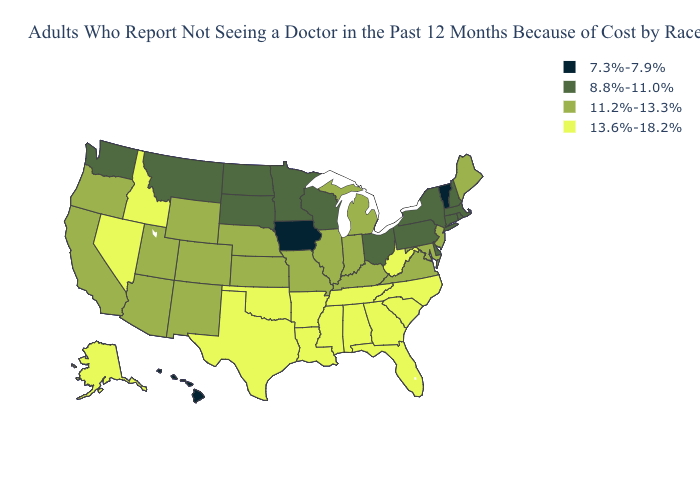Name the states that have a value in the range 13.6%-18.2%?
Keep it brief. Alabama, Alaska, Arkansas, Florida, Georgia, Idaho, Louisiana, Mississippi, Nevada, North Carolina, Oklahoma, South Carolina, Tennessee, Texas, West Virginia. What is the value of Alabama?
Give a very brief answer. 13.6%-18.2%. Does the map have missing data?
Write a very short answer. No. Does Hawaii have the lowest value in the USA?
Short answer required. Yes. Name the states that have a value in the range 13.6%-18.2%?
Write a very short answer. Alabama, Alaska, Arkansas, Florida, Georgia, Idaho, Louisiana, Mississippi, Nevada, North Carolina, Oklahoma, South Carolina, Tennessee, Texas, West Virginia. Name the states that have a value in the range 13.6%-18.2%?
Write a very short answer. Alabama, Alaska, Arkansas, Florida, Georgia, Idaho, Louisiana, Mississippi, Nevada, North Carolina, Oklahoma, South Carolina, Tennessee, Texas, West Virginia. What is the lowest value in states that border Delaware?
Answer briefly. 8.8%-11.0%. Does Kansas have the same value as Ohio?
Be succinct. No. Among the states that border Kentucky , does Illinois have the highest value?
Give a very brief answer. No. Among the states that border New York , which have the lowest value?
Keep it brief. Vermont. What is the value of Illinois?
Be succinct. 11.2%-13.3%. Which states hav the highest value in the Northeast?
Give a very brief answer. Maine, New Jersey. What is the value of Vermont?
Keep it brief. 7.3%-7.9%. Which states hav the highest value in the Northeast?
Answer briefly. Maine, New Jersey. What is the lowest value in the USA?
Give a very brief answer. 7.3%-7.9%. 